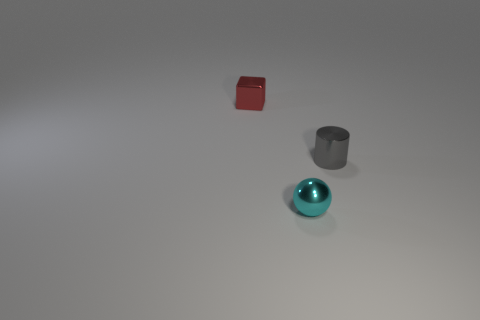Subtract all cyan cylinders. Subtract all blue cubes. How many cylinders are left? 1 Add 1 cyan objects. How many objects exist? 4 Subtract all cylinders. How many objects are left? 2 Subtract all purple balls. Subtract all tiny metal objects. How many objects are left? 0 Add 3 metal things. How many metal things are left? 6 Add 1 red shiny blocks. How many red shiny blocks exist? 2 Subtract 0 yellow cylinders. How many objects are left? 3 